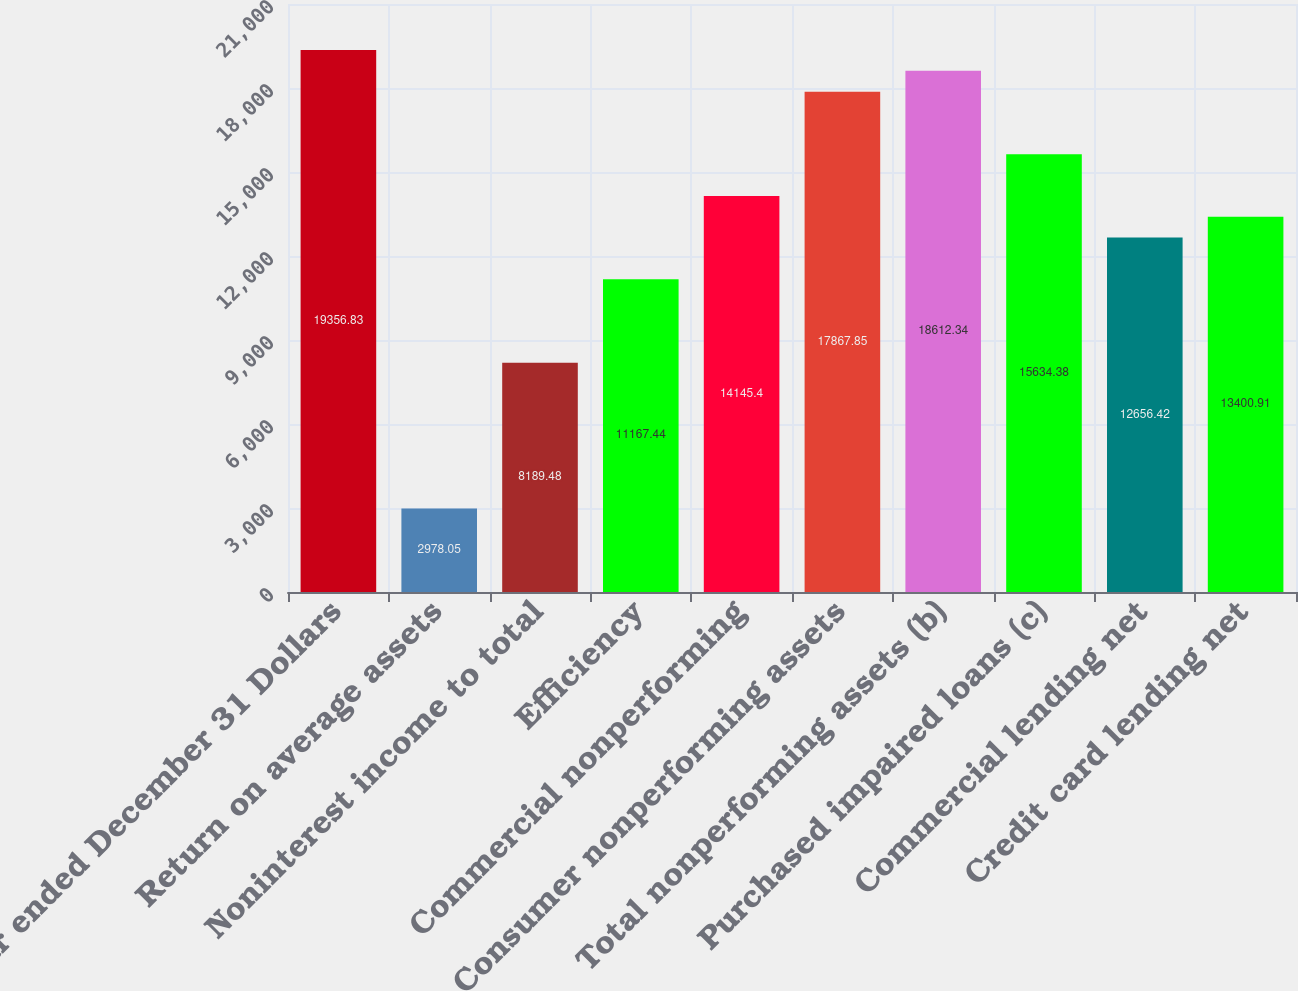<chart> <loc_0><loc_0><loc_500><loc_500><bar_chart><fcel>Year ended December 31 Dollars<fcel>Return on average assets<fcel>Noninterest income to total<fcel>Efficiency<fcel>Commercial nonperforming<fcel>Consumer nonperforming assets<fcel>Total nonperforming assets (b)<fcel>Purchased impaired loans (c)<fcel>Commercial lending net<fcel>Credit card lending net<nl><fcel>19356.8<fcel>2978.05<fcel>8189.48<fcel>11167.4<fcel>14145.4<fcel>17867.8<fcel>18612.3<fcel>15634.4<fcel>12656.4<fcel>13400.9<nl></chart> 